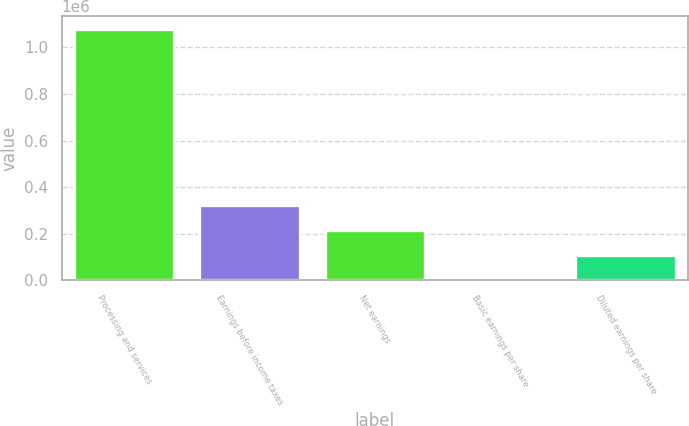Convert chart to OTSL. <chart><loc_0><loc_0><loc_500><loc_500><bar_chart><fcel>Processing and services<fcel>Earnings before income taxes<fcel>Net earnings<fcel>Basic earnings per share<fcel>Diluted earnings per share<nl><fcel>1.08065e+06<fcel>324196<fcel>216131<fcel>0.41<fcel>108065<nl></chart> 